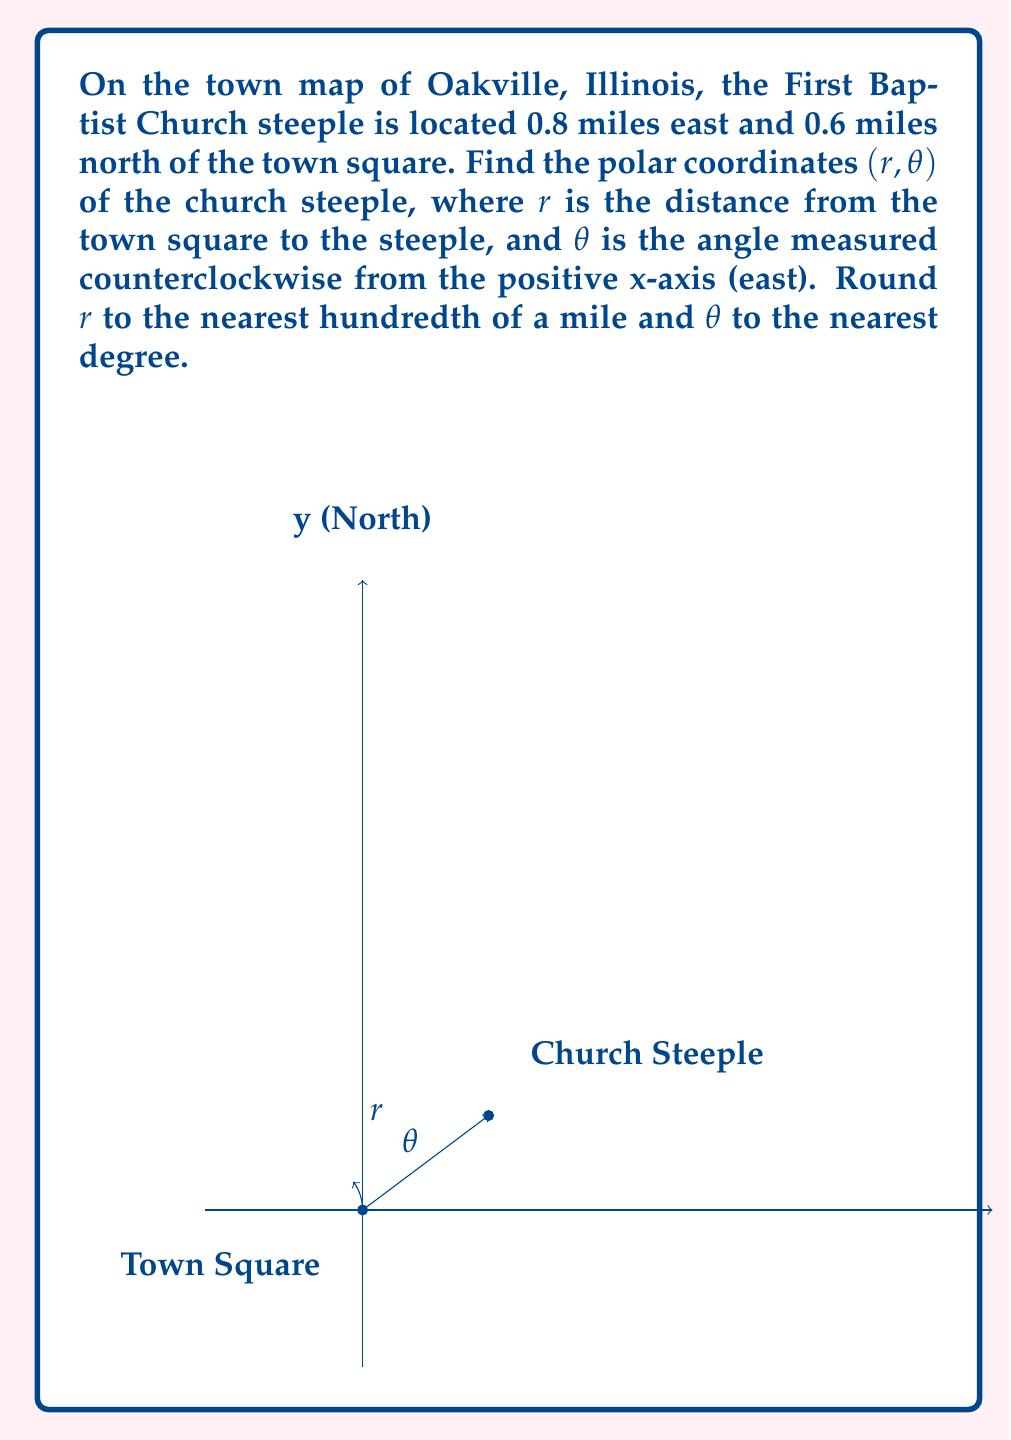Teach me how to tackle this problem. To find the polar coordinates $(r, \theta)$ of the church steeple, we need to convert the given Cartesian coordinates $(x, y) = (0.8, 0.6)$ to polar form.

1. Calculate $r$:
   $r$ represents the distance from the origin (town square) to the point (church steeple).
   We can find this using the Pythagorean theorem:
   
   $$r = \sqrt{x^2 + y^2} = \sqrt{0.8^2 + 0.6^2} = \sqrt{0.64 + 0.36} = \sqrt{1} = 1$$

2. Calculate $\theta$:
   $\theta$ is the angle measured counterclockwise from the positive x-axis to the line connecting the origin to the point.
   We can find this using the arctangent function:
   
   $$\theta = \arctan(\frac{y}{x}) = \arctan(\frac{0.6}{0.8}) \approx 0.6435 \text{ radians}$$

   To convert radians to degrees, multiply by $\frac{180°}{\pi}$:
   
   $$\theta = 0.6435 \times \frac{180°}{\pi} \approx 36.87°$$

3. Rounding:
   $r = 1$ (already to the nearest hundredth)
   $\theta \approx 37°$ (rounded to the nearest degree)

Therefore, the polar coordinates of the church steeple are approximately $(1, 37°)$.
Answer: $(1.00, 37°)$ 